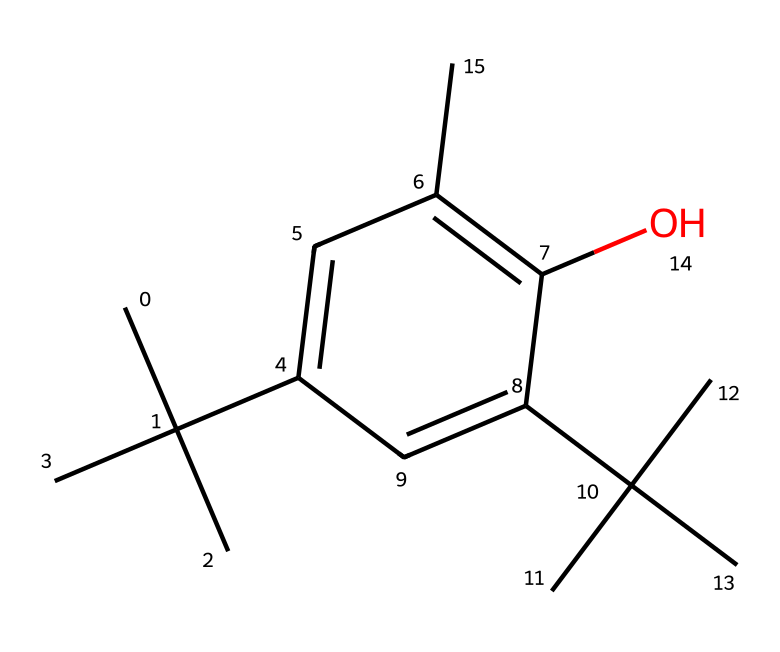What is the chemical name of this compound? The SMILES representation translates to a specific chemical structure, which is identified as butylated hydroxytoluene (BHT).
Answer: butylated hydroxytoluene How many carbon atoms are in the structure? By examining the SMILES, we can count the number of 'C' in the structure, which shows that there are 15 carbon atoms.
Answer: 15 How many hydroxyl (OH) groups are present in this chemical? The structure contains one 'O' indicating a hydroxyl group attached to the aromatic ring, specifically shown in the phenolic structure of BHT.
Answer: 1 What type of functional group is present in this chemical? The presence of the 'OH' group in the structure indicates it is a phenolic compound, specifically a phenol functional group.
Answer: phenol What is the empirical formula for butylated hydroxytoluene? From the count of elements derived from the SMILES, the empirical formula deduced is C15H24O.
Answer: C15H24O Does this structure exhibit any branch points in its carbon chains? Observing the structure, there are several branching points among the carbon chains where tertiary carbons branch off from the main chain.
Answer: Yes How does the structure suggest the compound's preservative qualities? The presence of multiple alkyl groups likely contributes to its hydrophobic nature, allowing it to inhibit oxidation and prolong shelf life, a key characteristic of preservatives.
Answer: Hydrophobic nature 